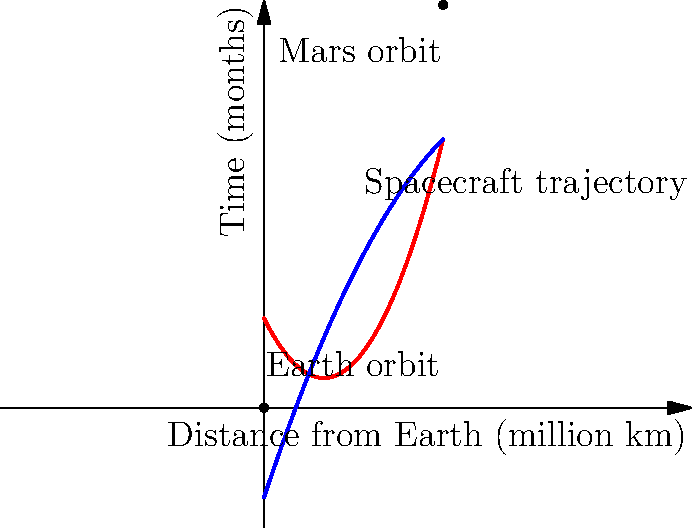As the mayor preparing to introduce the retired astronaut, you want to understand the basics of space travel. The chart shows the trajectory of a spacecraft traveling from Earth to Mars. Based on the graph, approximately how long does the journey take, and what's the maximum distance the spacecraft travels from Earth? To answer this question, we need to analyze the graph carefully:

1. The x-axis represents the distance from Earth in million kilometers.
2. The y-axis represents time in months.
3. The blue curve represents the spacecraft's trajectory.

To find the journey duration:
1. Locate the point where the blue curve intersects the y-axis (Earth's orbit).
2. Trace the curve to where it intersects Mars' orbit.
3. The y-coordinate of this intersection point gives us the journey time.

From the graph, we can see that the blue curve starts at (0,0) and ends at approximately (2,4.5) on the graph.

To find the maximum distance:
1. Locate the rightmost point of the blue curve.
2. The x-coordinate of this point gives us the maximum distance.

The curve reaches its maximum x-value at approximately 2 million km.

Therefore, the journey takes about 4.5 months, and the maximum distance from Earth is approximately 2 million km.
Answer: 4.5 months; 2 million km 